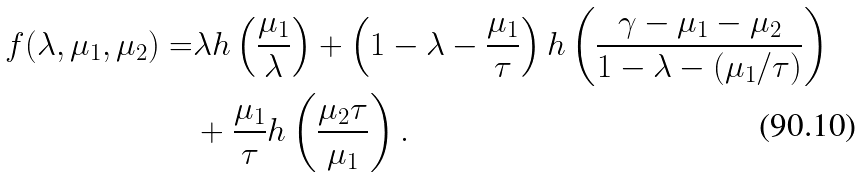Convert formula to latex. <formula><loc_0><loc_0><loc_500><loc_500>f ( \lambda , \mu _ { 1 } , \mu _ { 2 } ) = & \lambda h \left ( \frac { \mu _ { 1 } } { \lambda } \right ) + \left ( 1 - \lambda - \frac { \mu _ { 1 } } { \tau } \right ) h \left ( \frac { \gamma - \mu _ { 1 } - \mu _ { 2 } } { 1 - \lambda - ( \mu _ { 1 } / \tau ) } \right ) \\ & + \frac { \mu _ { 1 } } \tau h \left ( \frac { \mu _ { 2 } \tau } { \mu _ { 1 } } \right ) .</formula> 